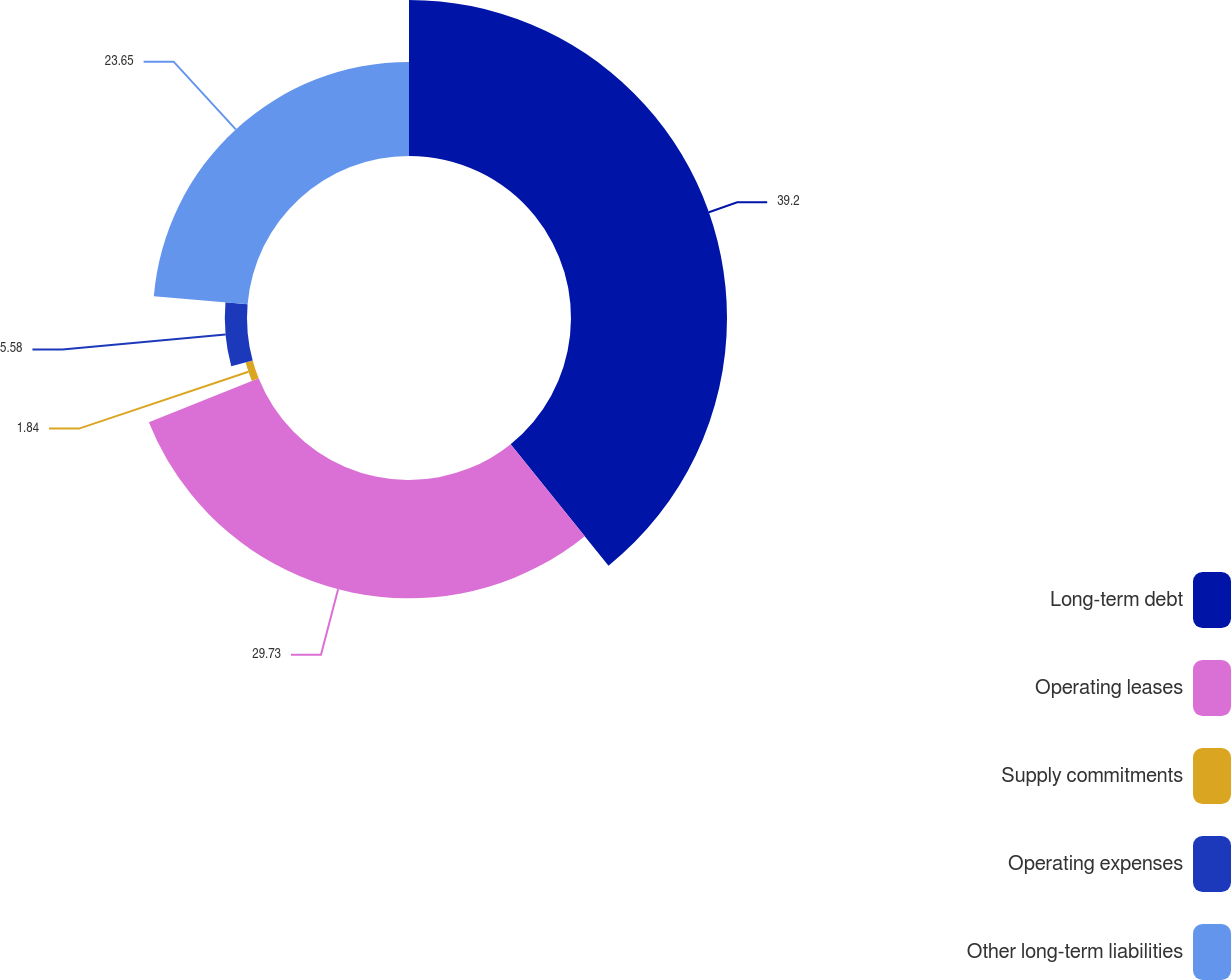Convert chart. <chart><loc_0><loc_0><loc_500><loc_500><pie_chart><fcel>Long-term debt<fcel>Operating leases<fcel>Supply commitments<fcel>Operating expenses<fcel>Other long-term liabilities<nl><fcel>39.21%<fcel>29.73%<fcel>1.84%<fcel>5.58%<fcel>23.65%<nl></chart> 